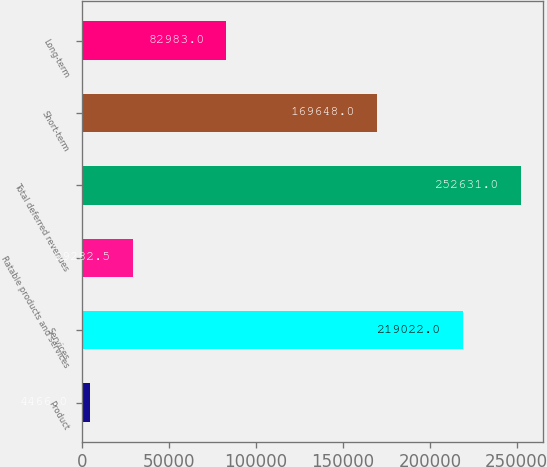<chart> <loc_0><loc_0><loc_500><loc_500><bar_chart><fcel>Product<fcel>Services<fcel>Ratable products and services<fcel>Total deferred revenues<fcel>Short-term<fcel>Long-term<nl><fcel>4466<fcel>219022<fcel>29282.5<fcel>252631<fcel>169648<fcel>82983<nl></chart> 